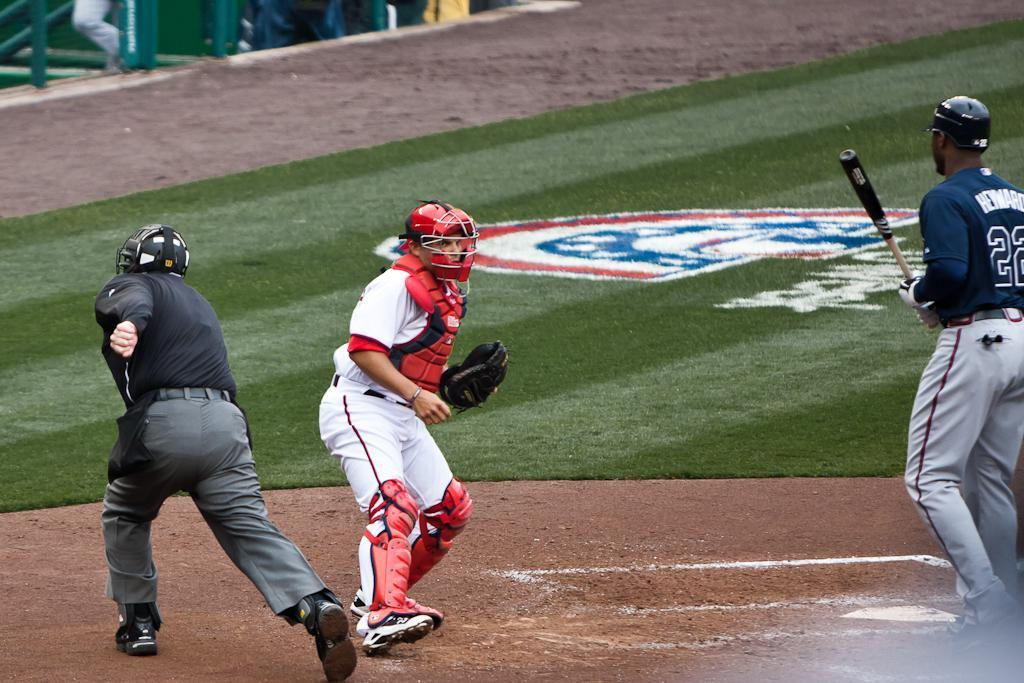<image>
Render a clear and concise summary of the photo. Baseball playing wearing number 22 holding a bat. 